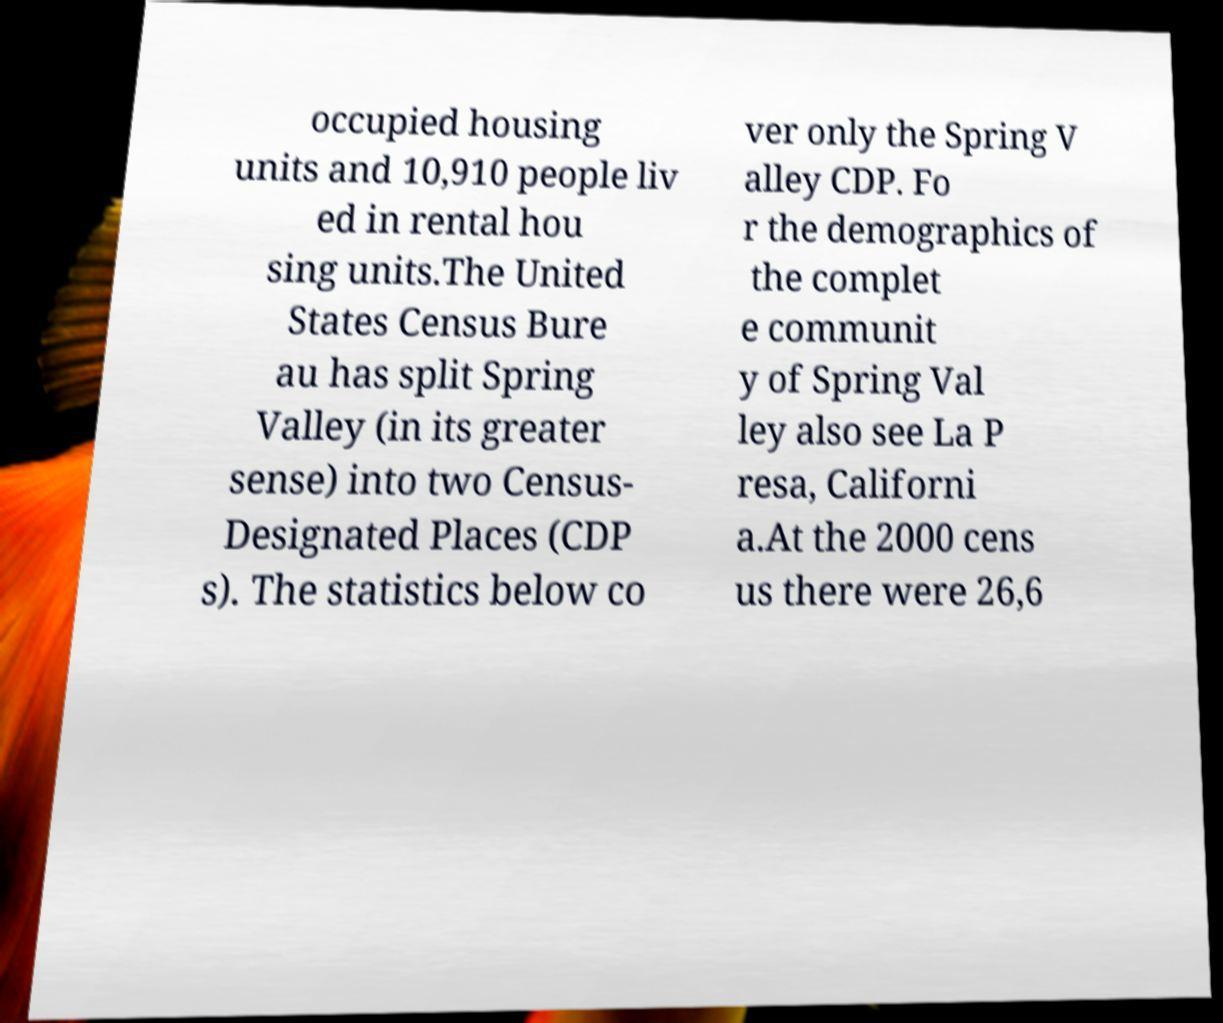I need the written content from this picture converted into text. Can you do that? occupied housing units and 10,910 people liv ed in rental hou sing units.The United States Census Bure au has split Spring Valley (in its greater sense) into two Census- Designated Places (CDP s). The statistics below co ver only the Spring V alley CDP. Fo r the demographics of the complet e communit y of Spring Val ley also see La P resa, Californi a.At the 2000 cens us there were 26,6 